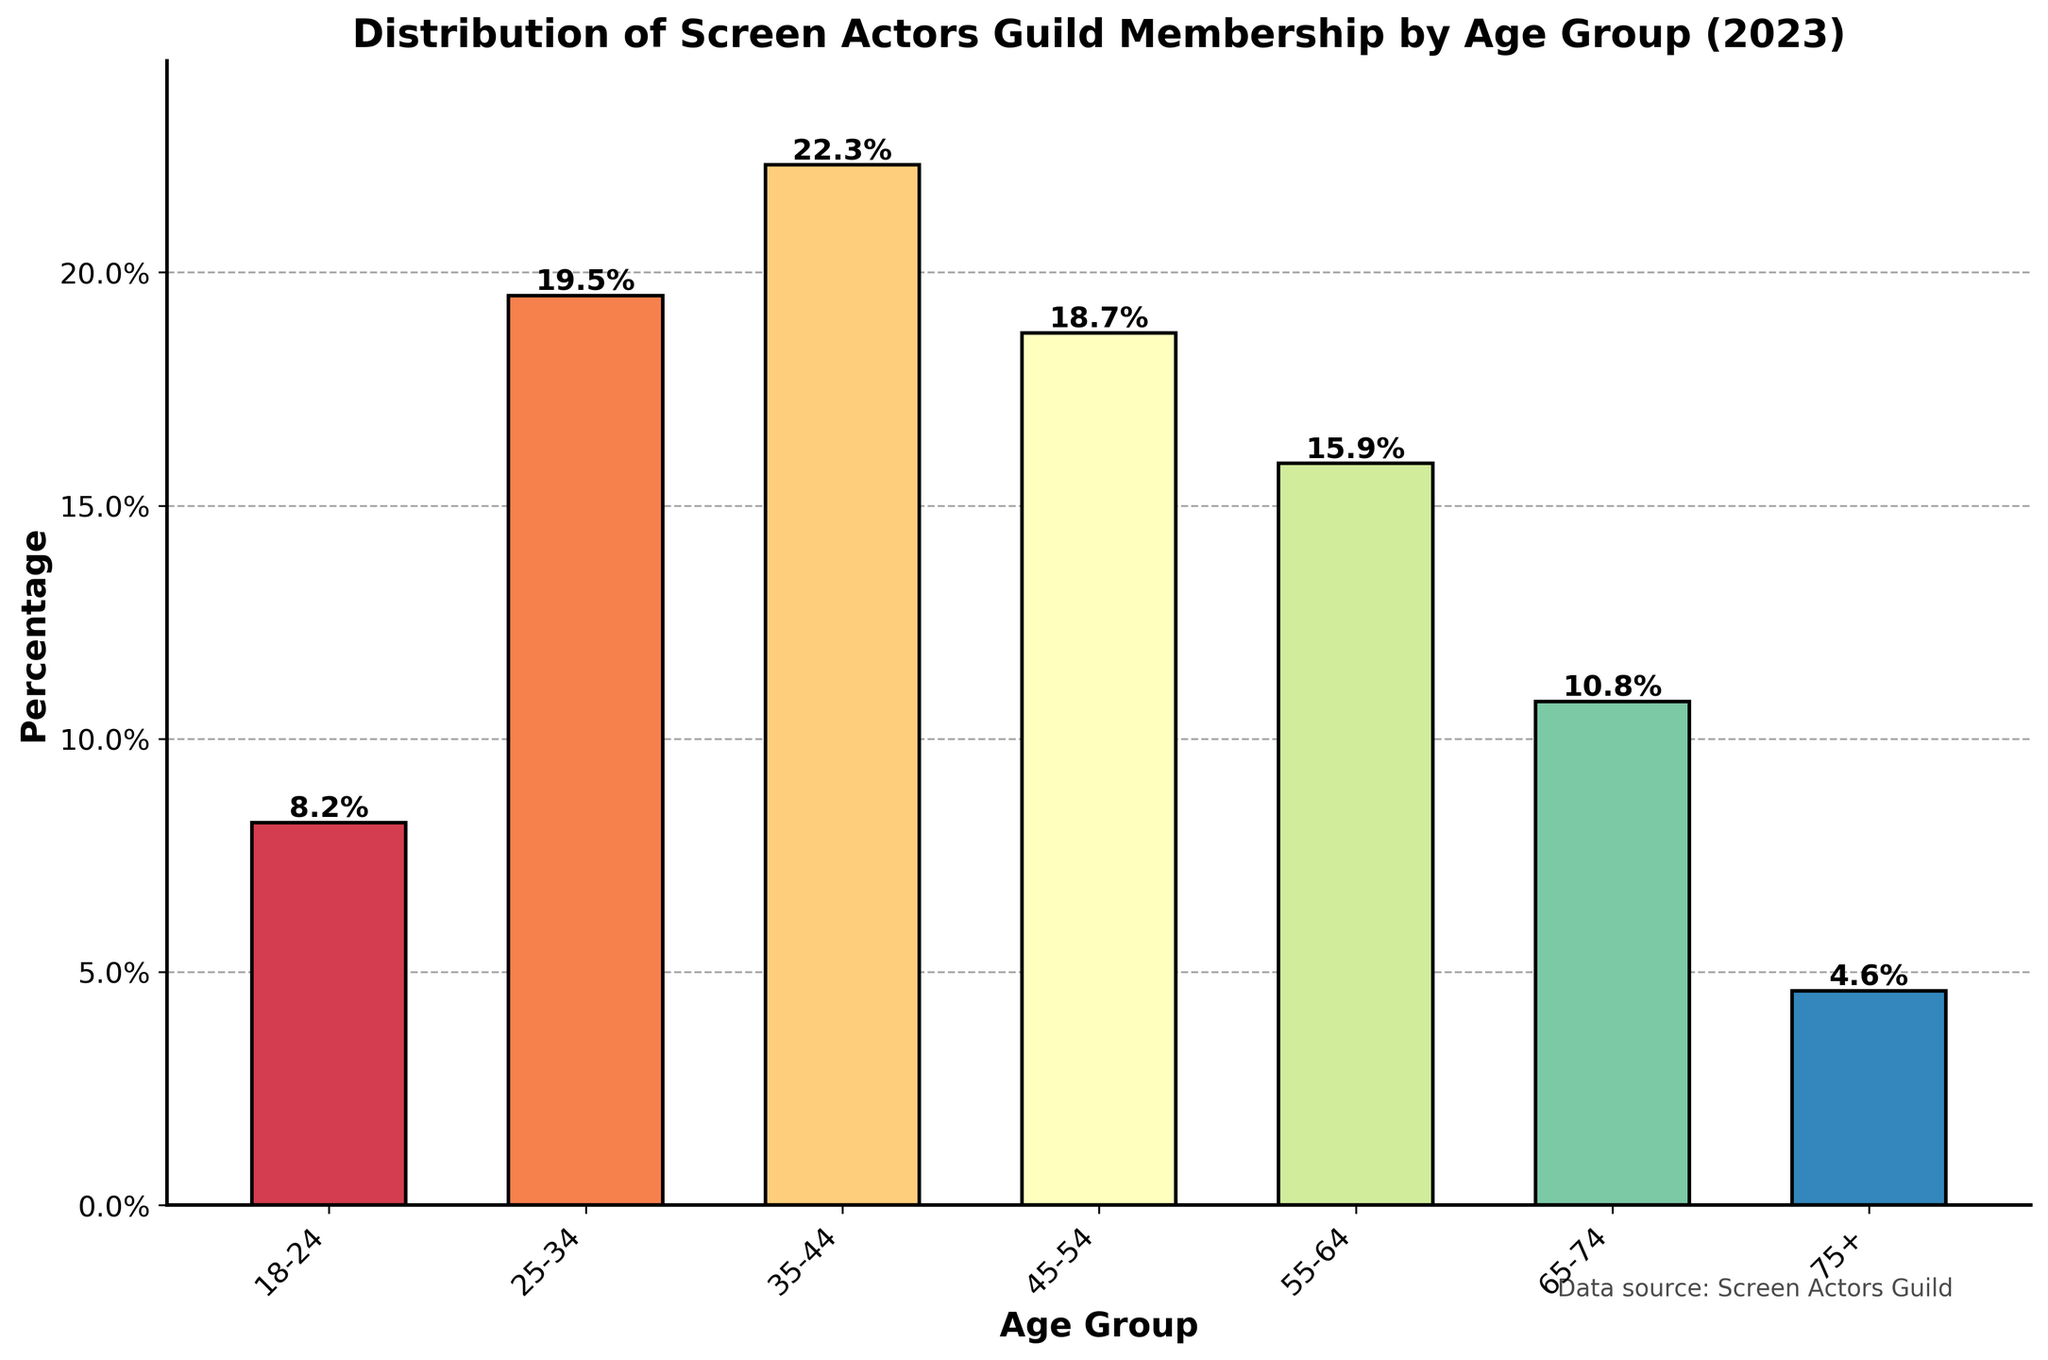What age group has the highest percentage of SAG members? The bar representing the 35-44 age group is the tallest on the plot, indicating it has the highest percentage.
Answer: 35-44 What is the combined percentage of SAG members aged 55 and above? Summing the percentages of the 55-64, 65-74, and 75+ age groups: 15.9% + 10.8% + 4.6% = 31.3%
Answer: 31.3% Which age group has the lowest percentage of SAG members, and what is that percentage? The bar representing the 75+ age group is the shortest on the plot, indicating it has the lowest percentage, at 4.6%.
Answer: 75+, 4.6% How does the percentage of SAG members aged 25-34 compare to those aged 45-54? The percentage for the 25-34 age group (19.5%) is slightly higher than that for the 45-54 age group (18.7%).
Answer: 25-34 is higher What is the difference in percentage between the 35-44 age group and the 65-74 age group? Subtracting the percentage of the 65-74 age group (10.8%) from the 35-44 age group (22.3%) gives: 22.3% - 10.8% = 11.5%
Answer: 11.5% What percentage of the SAG members are aged 18-44? Summing the percentages of the 18-24, 25-34, and 35-44 age groups: 8.2% + 19.5% + 22.3% = 50.0%
Answer: 50.0% Which two age groups have the closest percentages of SAG members? The age groups 45-54 (18.7%) and 25-34 (19.5%) have very close percentages. The difference is 19.5% - 18.7% = 0.8%.
Answer: 45-54 and 25-34 Are the majority of SAG members under 45 years of age? Summing the percentages of the 18-24, 25-34, and 35-44 age groups: 8.2% + 19.5% + 22.3% = 50.0%. Since 50.0% is not greater than 50%, the majority are not under 45 years.
Answer: No 